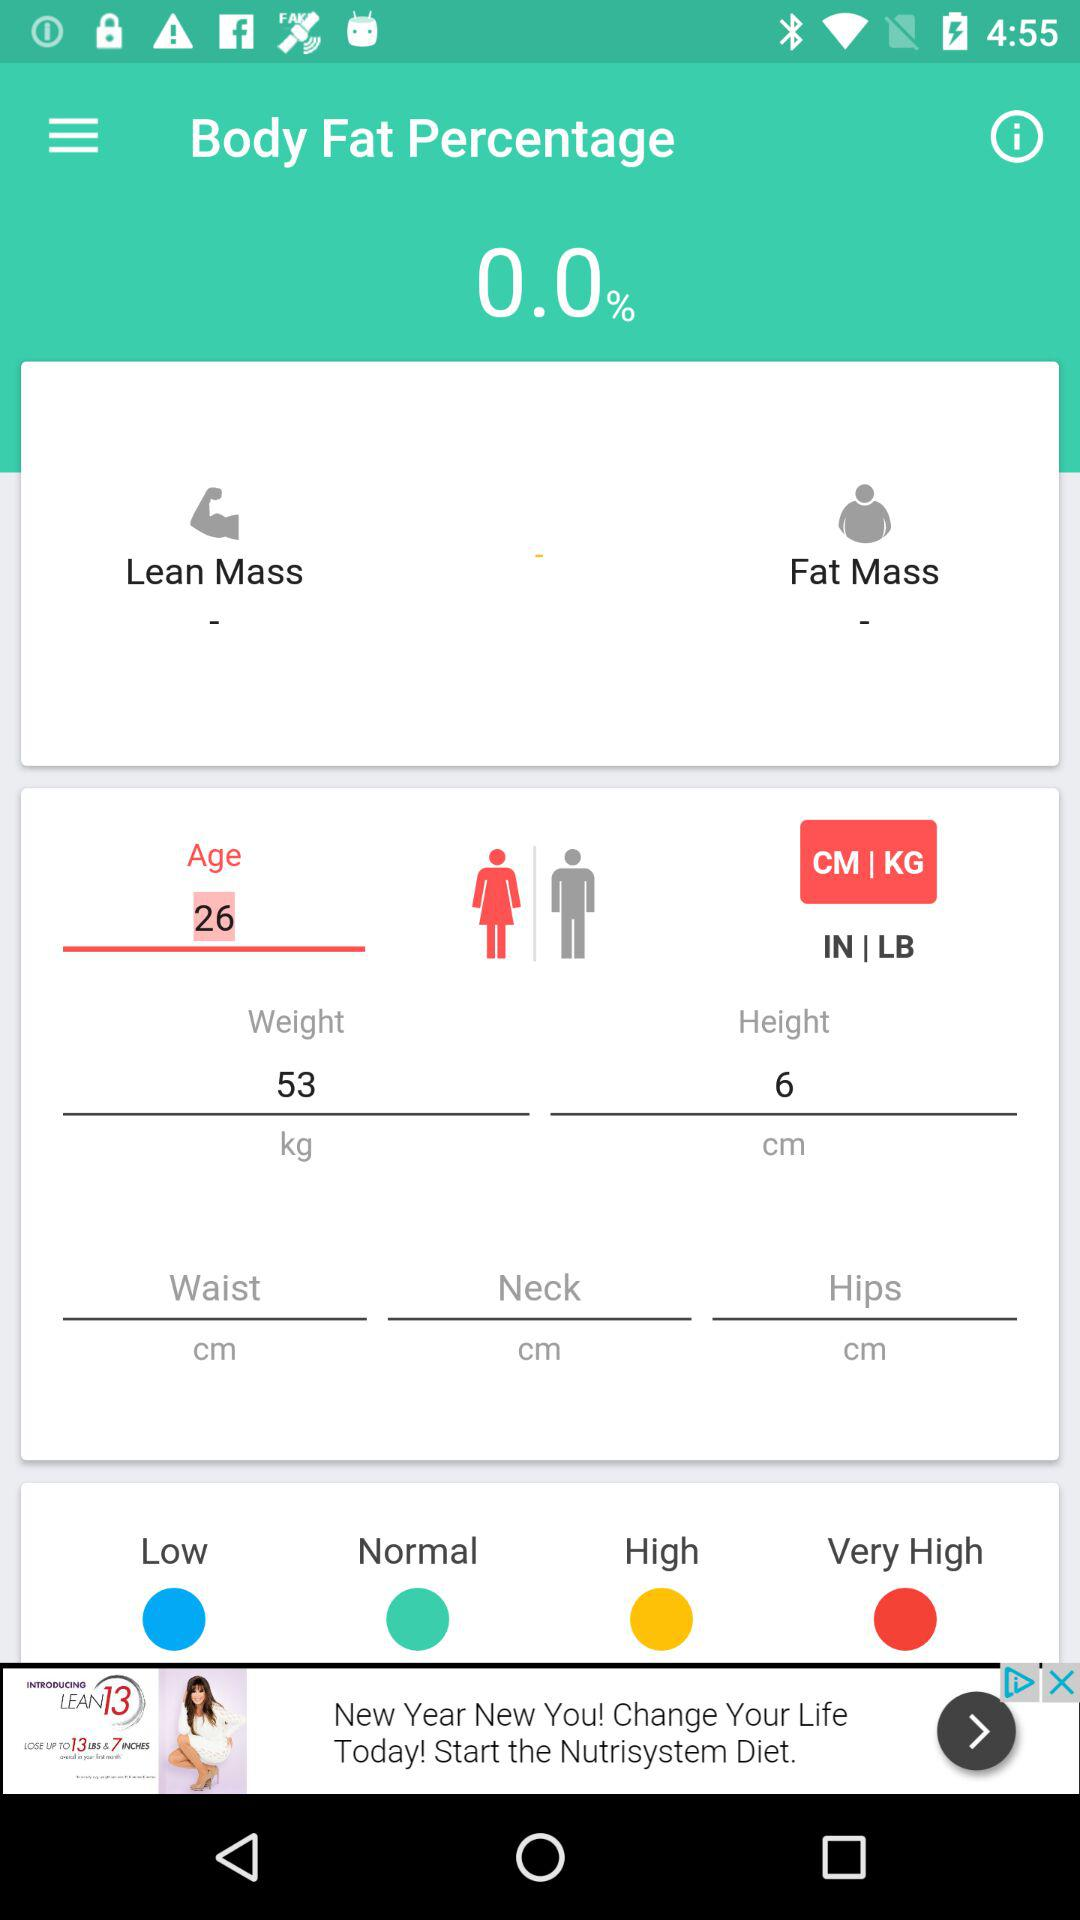What is the mentioned weight? The mentioned weight is 53 kg. 